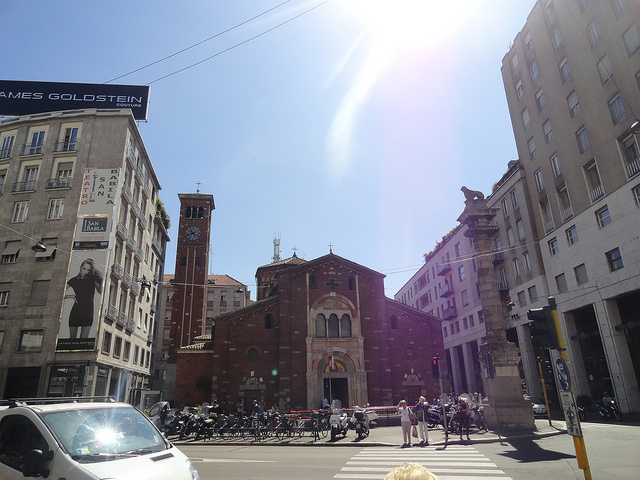What cultural significance does this building hold in Milan? San Lorenzo Maggiore holds substantial cultural significance in Milan due to its rich, layered history. It's not only a place of worship but also a symbol of the historical continuity from the Roman times through various epochs, serving as a silent witness to the city’s transformations. It's a beloved landmark where various cultural events and religious ceremonies take place, deeply integrated into the social and cultural fabric of Milan. Are there regular events or traditions associated with it? Indeed, the Basilica hosts several religious ceremonies throughout the year, particularly during major Christian holidays like Easter and Christmas. Additionally, it often serves as a venue for concerts and exhibitions that highlight not just religious themes but also broader cultural elements, bringing a diverse crowd to its historic grounds. 